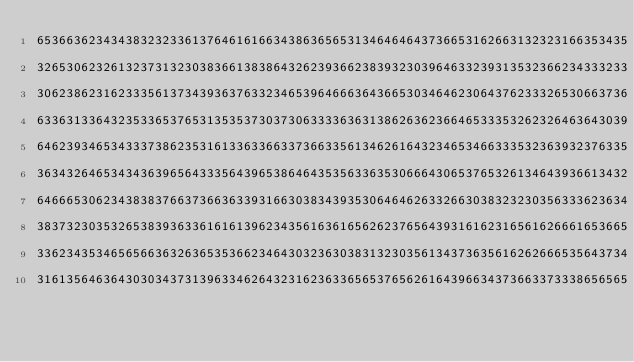Convert code to text. <code><loc_0><loc_0><loc_500><loc_500><_YAML_>65366362343438323233613764616166343863656531346464643736653162663132323166353435
32653062326132373132303836613838643262393662383932303964633239313532366234333233
30623862316233356137343936376332346539646663643665303464623064376233326530663736
63363133643235336537653135353730373063333636313862636236646533353262326463643039
64623934653433373862353161336336633736633561346261643234653466333532363932376335
36343264653434363965643335643965386464353563363530666430653765326134643936613432
64666530623438383766373663633931663038343935306464626332663038323230356333623634
38373230353265383936336161613962343561636165626237656439316162316561626661653665
33623435346565663632636535366234643032363038313230356134373635616262666535643734
31613564636430303437313963346264323162363365653765626164396634373663373338656565</code> 